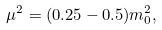Convert formula to latex. <formula><loc_0><loc_0><loc_500><loc_500>\mu ^ { 2 } = ( 0 . 2 5 - 0 . 5 ) m _ { 0 } ^ { 2 } ,</formula> 